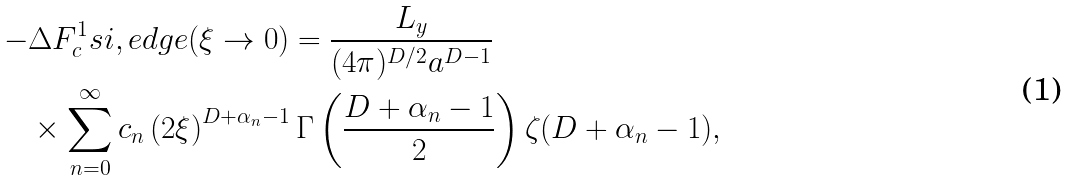Convert formula to latex. <formula><loc_0><loc_0><loc_500><loc_500>- & \Delta F _ { c } ^ { 1 } s i , e d g e ( \xi \rightarrow 0 ) = \frac { L _ { y } } { ( 4 \pi ) ^ { D / 2 } a ^ { D - 1 } } \\ & \times \sum _ { n = 0 } ^ { \infty } c _ { n } \left ( 2 \xi \right ) ^ { D + \alpha _ { n } - 1 } \Gamma \left ( \frac { D + \alpha _ { n } - 1 } { 2 } \right ) \zeta ( D + \alpha _ { n } - 1 ) ,</formula> 